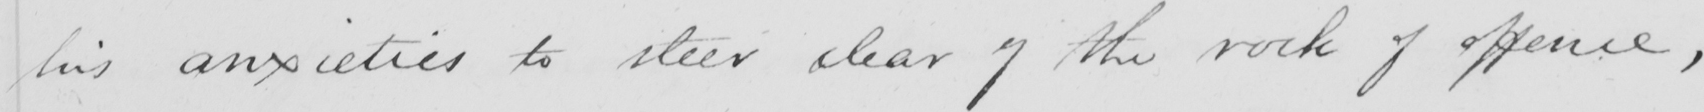Please transcribe the handwritten text in this image. his anxieties to steer clear of the rock of offence , 